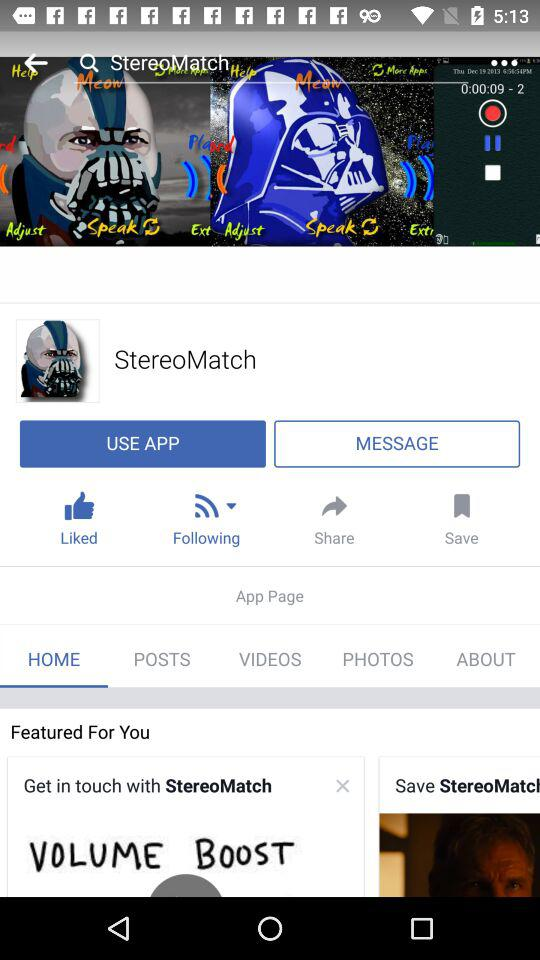Which option is selected? The selected option is "HOME". 